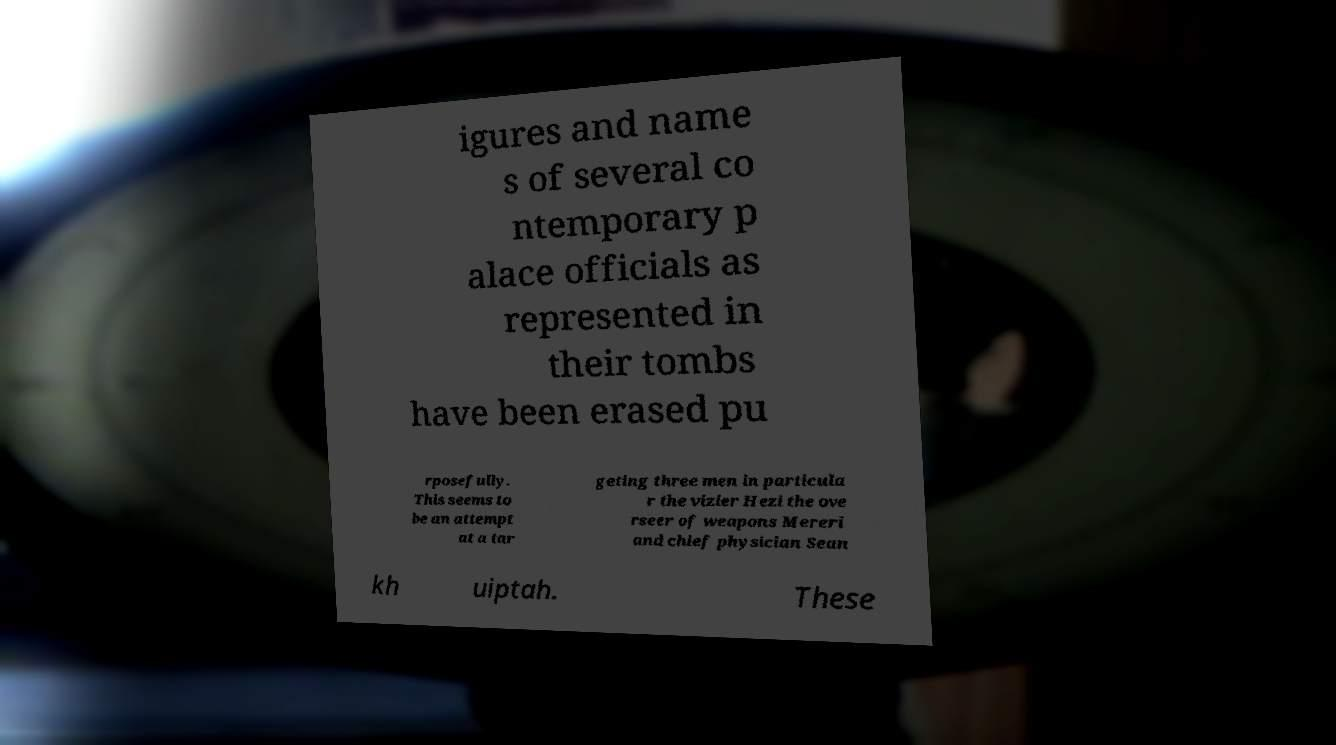Please read and relay the text visible in this image. What does it say? igures and name s of several co ntemporary p alace officials as represented in their tombs have been erased pu rposefully. This seems to be an attempt at a tar geting three men in particula r the vizier Hezi the ove rseer of weapons Mereri and chief physician Sean kh uiptah. These 